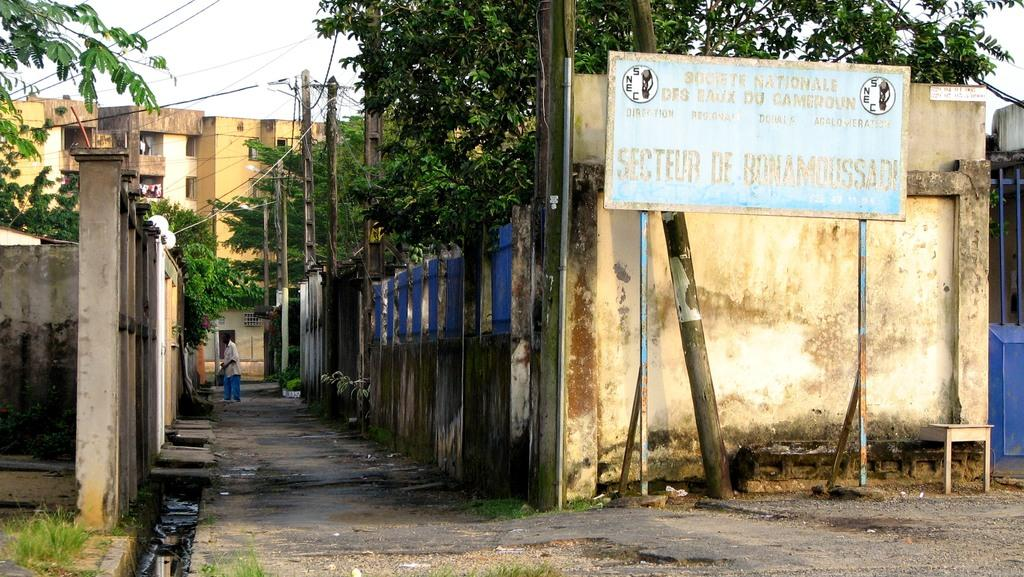What is the main object in the image? There is a name board in the image. What else can be seen in the image besides the name board? There is a table, grass, trees, poles, wires, buildings, a person standing on the road, objects, and the sky visible in the background. Can you describe the environment in the image? The image shows an outdoor setting with trees, grass, and buildings. There are also poles and wires present. What is the person in the image doing? The person is standing on the road. What type of appliance is being used by the person's father in the image? There is no person's father or appliance present in the image. 